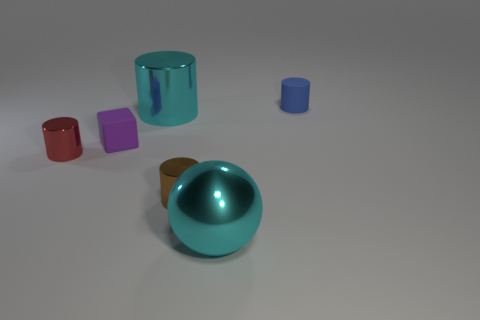Subtract all blue cylinders. How many cylinders are left? 3 Subtract all metallic cylinders. How many cylinders are left? 1 Subtract 0 purple cylinders. How many objects are left? 6 Subtract all cylinders. How many objects are left? 2 Subtract 1 balls. How many balls are left? 0 Subtract all red cubes. Subtract all brown spheres. How many cubes are left? 1 Subtract all gray balls. How many brown cylinders are left? 1 Subtract all tiny balls. Subtract all cyan metal cylinders. How many objects are left? 5 Add 2 cylinders. How many cylinders are left? 6 Add 4 rubber cylinders. How many rubber cylinders exist? 5 